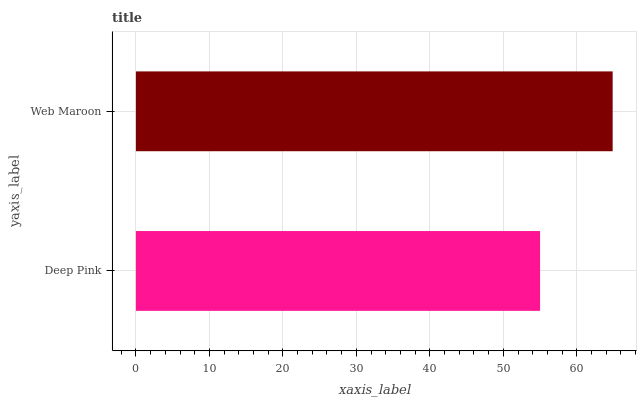Is Deep Pink the minimum?
Answer yes or no. Yes. Is Web Maroon the maximum?
Answer yes or no. Yes. Is Web Maroon the minimum?
Answer yes or no. No. Is Web Maroon greater than Deep Pink?
Answer yes or no. Yes. Is Deep Pink less than Web Maroon?
Answer yes or no. Yes. Is Deep Pink greater than Web Maroon?
Answer yes or no. No. Is Web Maroon less than Deep Pink?
Answer yes or no. No. Is Web Maroon the high median?
Answer yes or no. Yes. Is Deep Pink the low median?
Answer yes or no. Yes. Is Deep Pink the high median?
Answer yes or no. No. Is Web Maroon the low median?
Answer yes or no. No. 